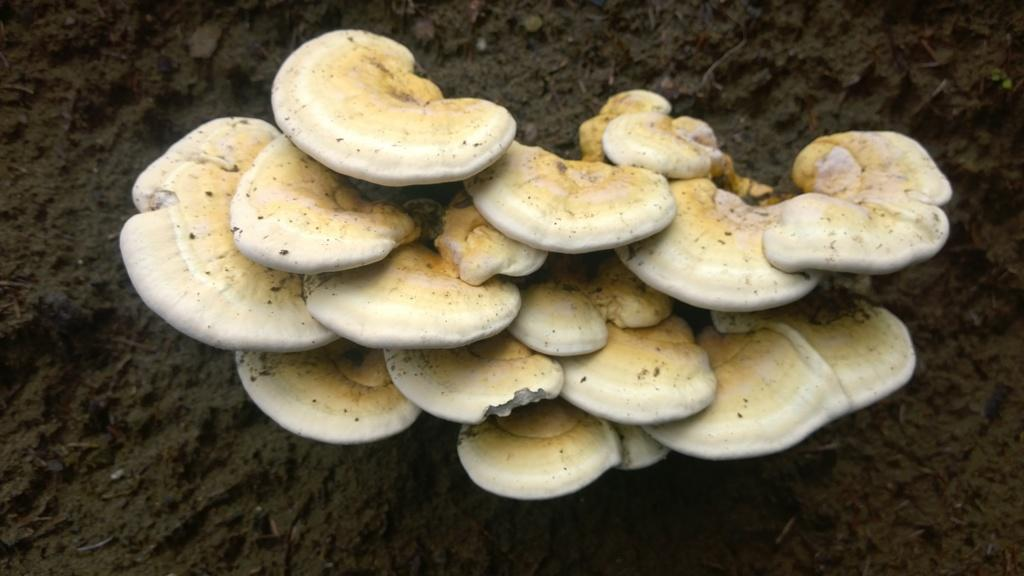What is the main subject in the center of the image? There are mushrooms in the center of the image. What type of terrain is visible at the bottom of the image? There is sand at the bottom of the image. What type of glue can be seen holding the mushrooms together in the image? There is no glue present in the image; the mushrooms are not attached to each other. How many groups of mushrooms can be seen in the image? There is only one group of mushrooms in the image, as they are all together in the center. 